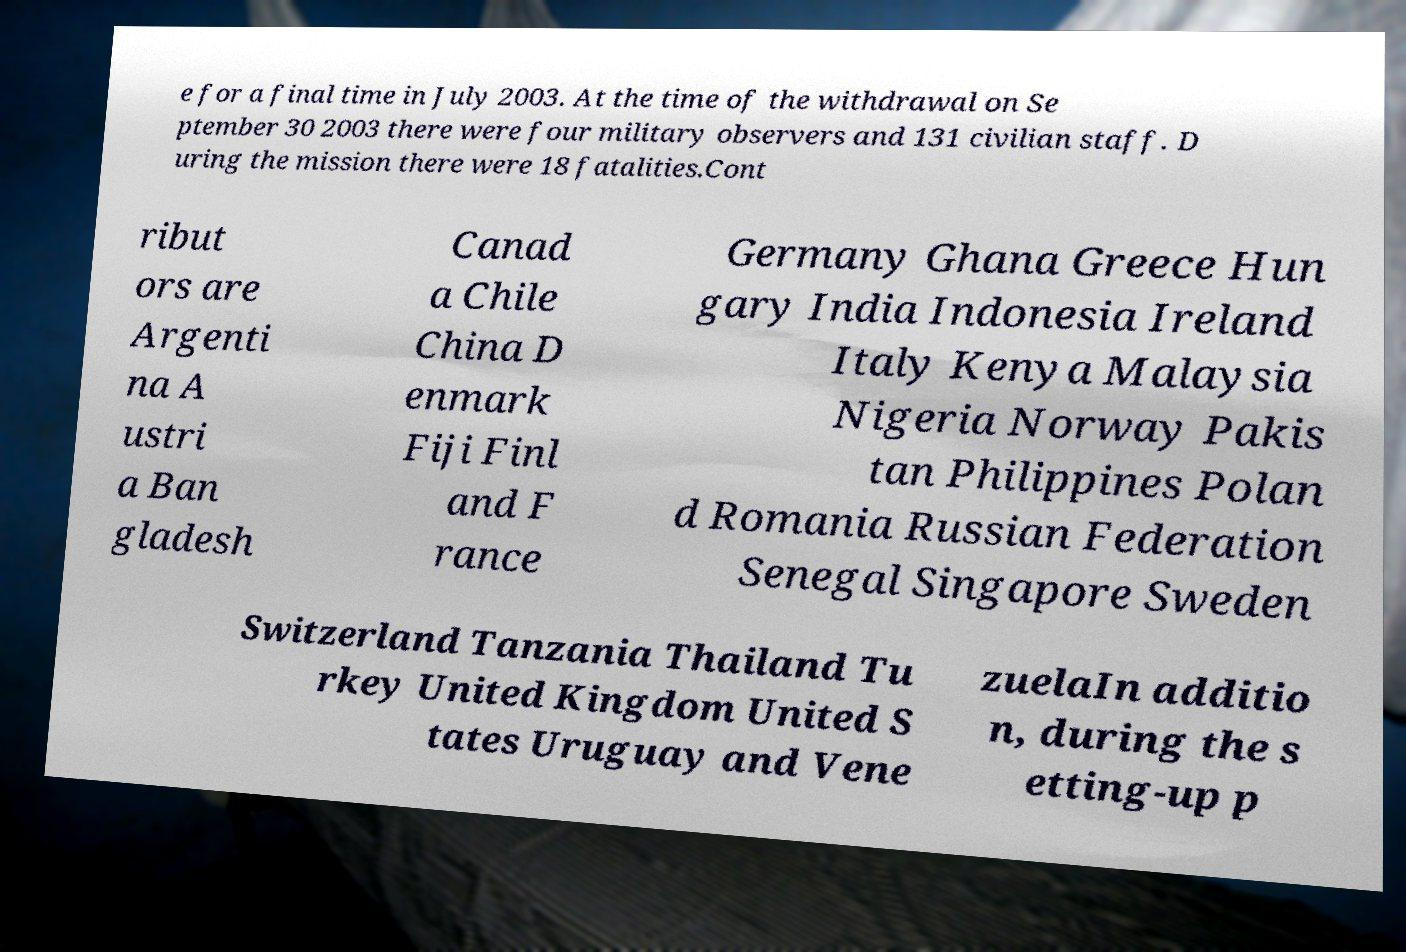Please read and relay the text visible in this image. What does it say? e for a final time in July 2003. At the time of the withdrawal on Se ptember 30 2003 there were four military observers and 131 civilian staff. D uring the mission there were 18 fatalities.Cont ribut ors are Argenti na A ustri a Ban gladesh Canad a Chile China D enmark Fiji Finl and F rance Germany Ghana Greece Hun gary India Indonesia Ireland Italy Kenya Malaysia Nigeria Norway Pakis tan Philippines Polan d Romania Russian Federation Senegal Singapore Sweden Switzerland Tanzania Thailand Tu rkey United Kingdom United S tates Uruguay and Vene zuelaIn additio n, during the s etting-up p 